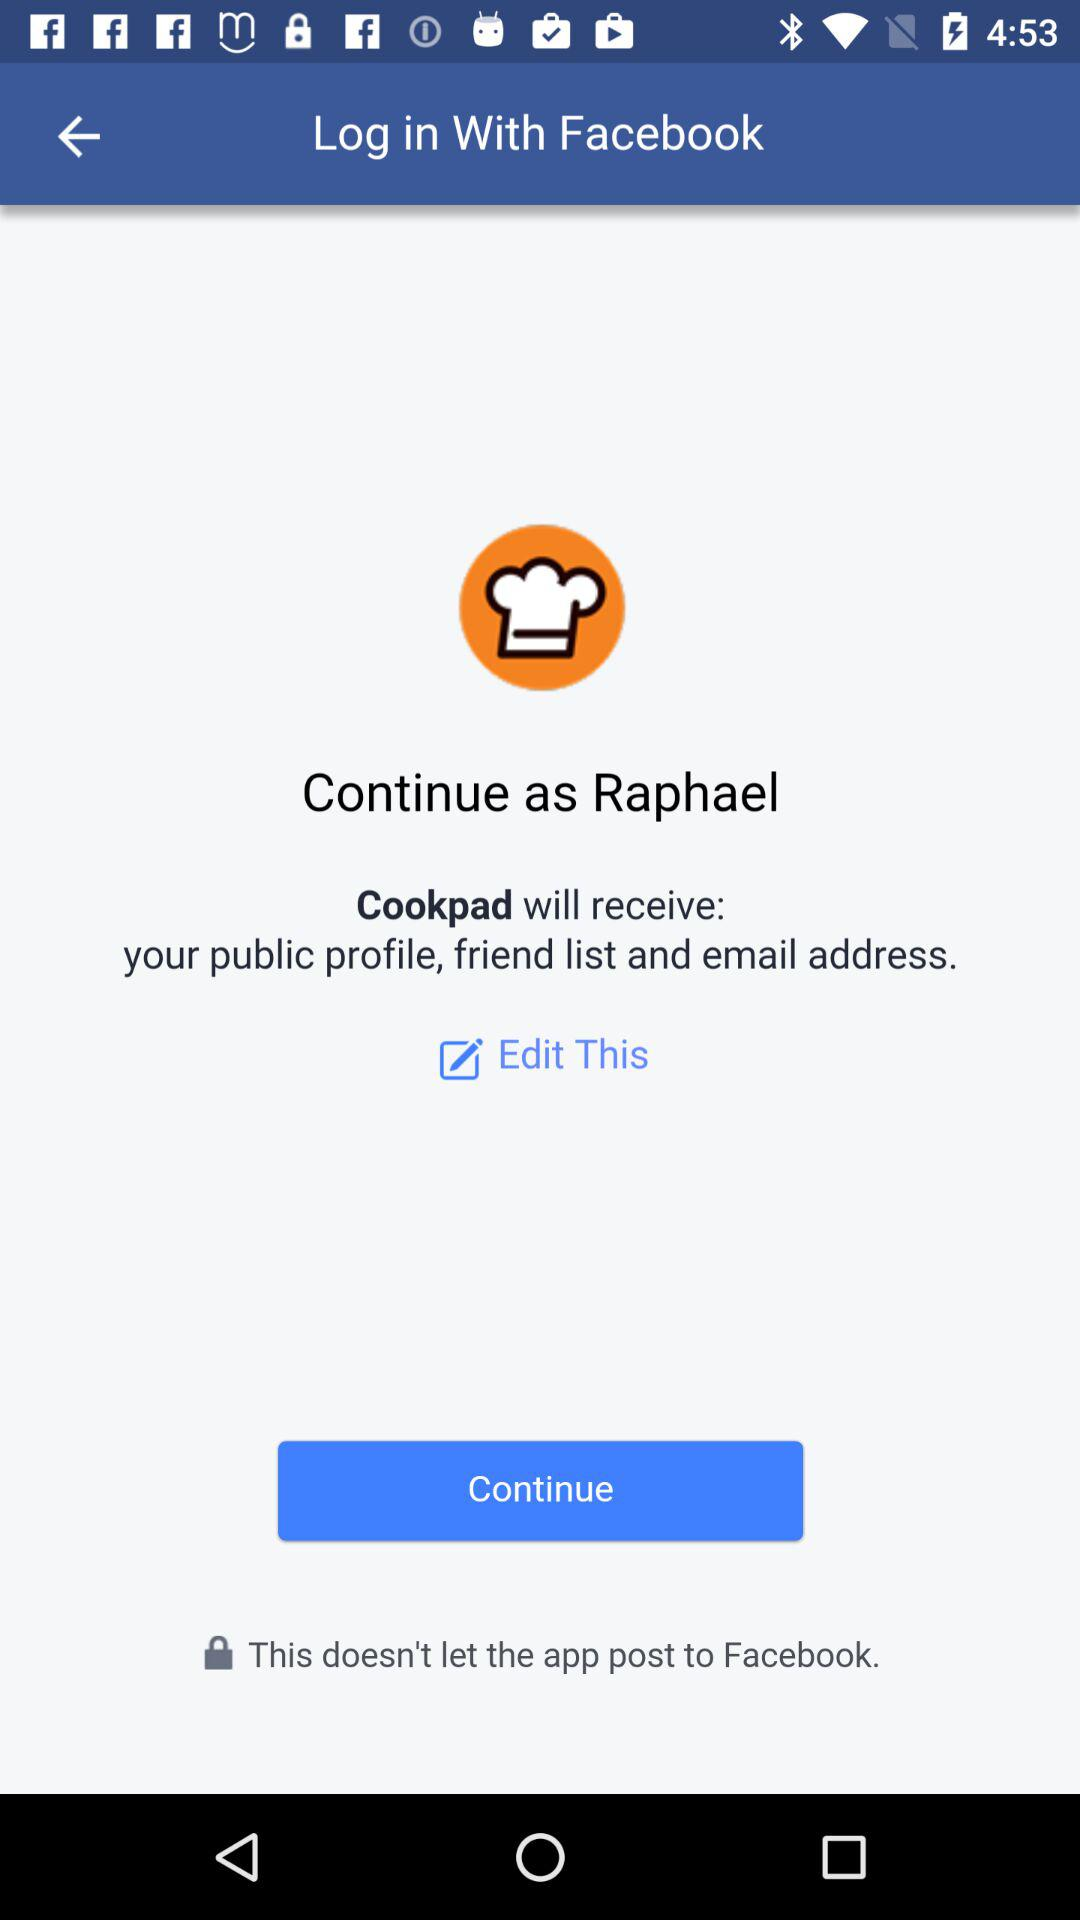What is the application name? The applications' names are "Facebook" and "Cookpad". 